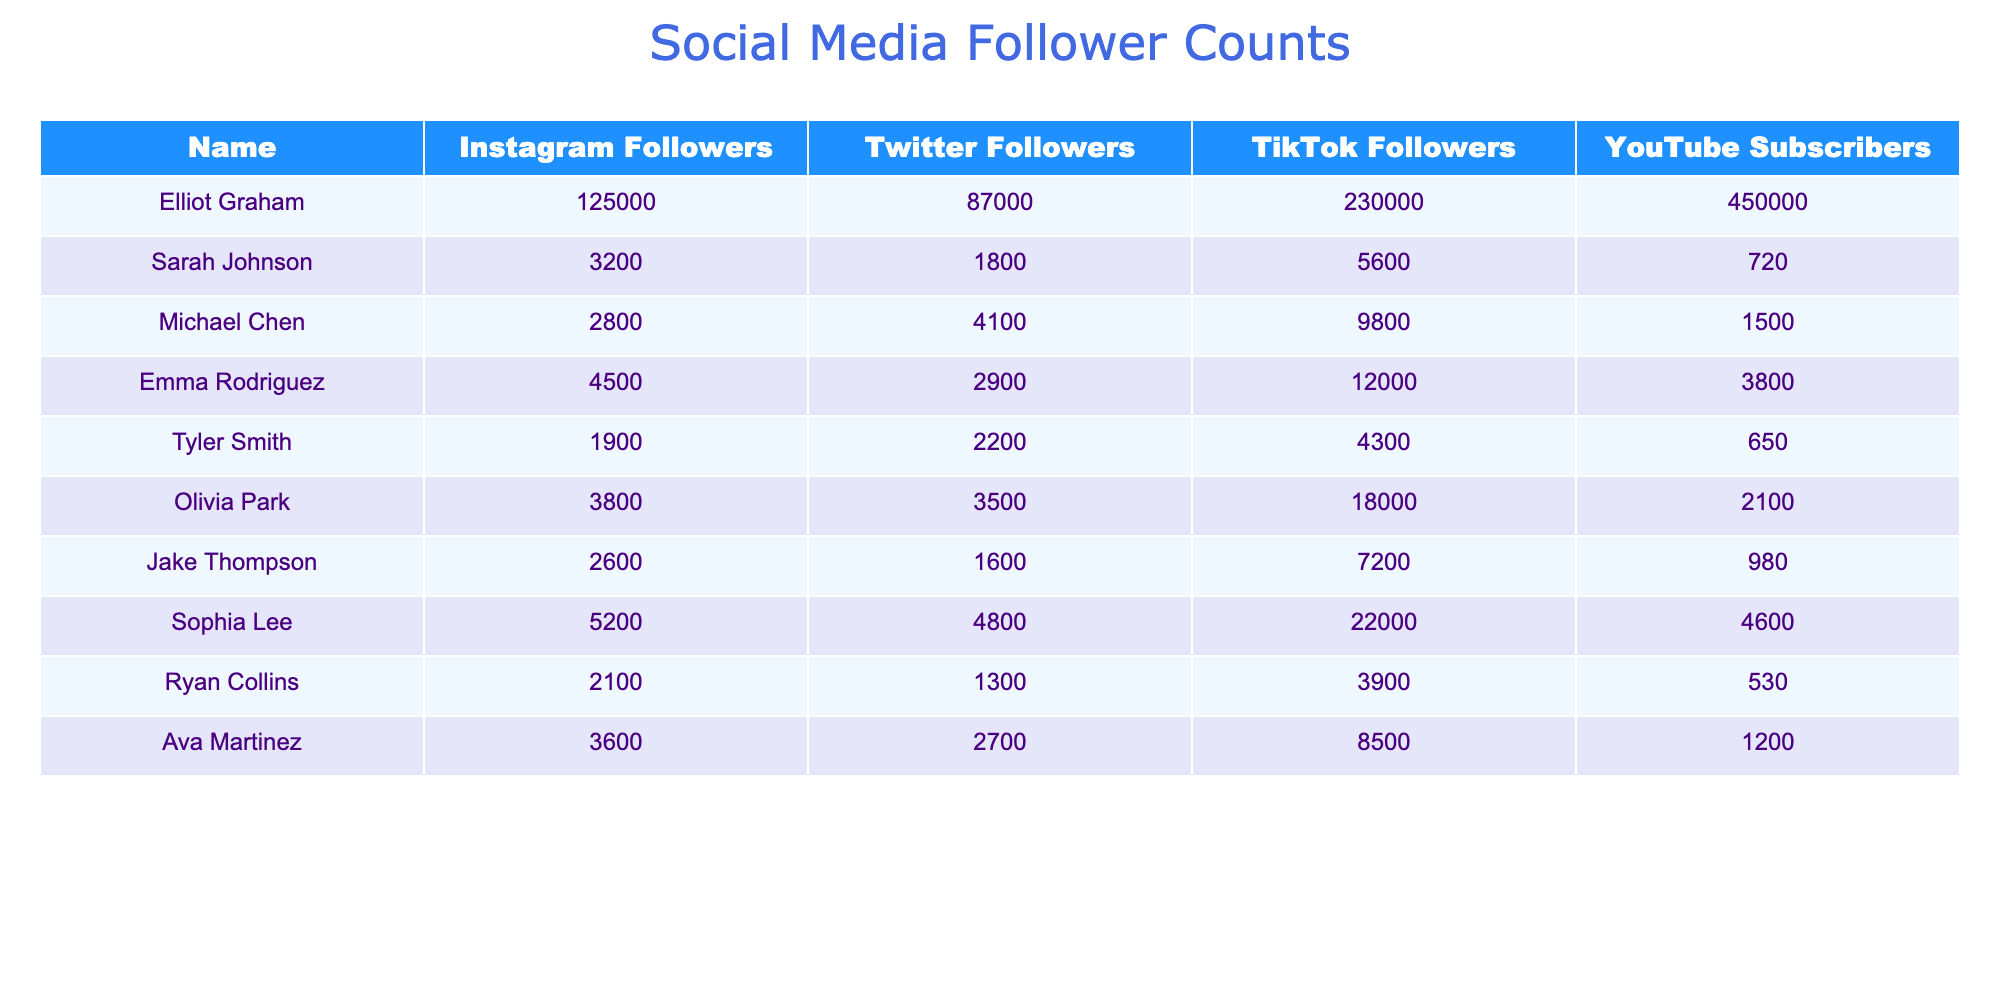What is Elliot Graham's total number of followers across all platforms? To find Elliot Graham's total followers, we add his followers from Instagram (125,000), Twitter (87,000), TikTok (230,000), and YouTube (450,000): 125000 + 87000 + 230000 + 450000 = 892000.
Answer: 892000 Which classmate has the most followers on TikTok? By comparing the TikTok follower counts, we see that Elliot Graham has 230,000 followers, which is more than any other classmate's TikTok counts.
Answer: Elliot Graham What is the average number of YouTube subscribers for the classmates listed? First, we list the YouTube subscribers: 450000 (Elliot) + 720 (Sarah) + 1500 (Michael) + 3800 (Emma) + 650 (Tyler) + 2100 (Olivia) + 980 (Jake) + 4600 (Sophia) + 530 (Ryan) + 1200 (Ava) = 456080. There are 10 classmates, so the average is 456080 / 10 = 45608.
Answer: 45608 Does Sarah Johnson have more Twitter followers than Emma Rodriguez? Sarah Johnson has 1,800 Twitter followers while Emma Rodriguez has 2,900. Since 1,800 is less than 2,900, the answer is no.
Answer: No Who has the least number of followers across all platforms combined? We calculate the total followers for each classmate and find the minimum. For instance, Sarah Johnson: 3200 + 1800 + 5600 + 720 = 11200; Michael Chen: 2800 + 4100 + 9800 + 1500 = 18200; and so on. Olivia Park has the least total with 3500 + 3800 + 18000 + 2100 = 26500 followers.
Answer: Sarah Johnson What is the difference in the number of Instagram followers between Elliot Graham and Sophia Lee? Elliot Graham has 125,000 Instagram followers and Sophia Lee has 5,200. The difference is 125000 - 5200 = 119800.
Answer: 119800 Who has more total followers: Tyler Smith or Ava Martinez? Tyler Smith: 1900 + 2200 + 4300 + 650 = 10150; Ava Martinez: 3600 + 2700 + 8500 + 1200 = 16000. Since 16000 is greater than 10150, Ava Martinez has more total followers than Tyler Smith.
Answer: Ava Martinez What percentage of Elliot Graham's total followers come from TikTok? Elliot's TikTok followers are 230,000 and his total fans are 892,000. The percentage is (230000 / 892000) * 100 ≈ 25.8%.
Answer: 25.8% Which platform gives Sarah Johnson the highest follower count? Sarah Johnson has 3,200 on Instagram, 1,800 on Twitter, 5,600 on TikTok, and 720 on YouTube. The highest count is from TikTok.
Answer: TikTok Are there any classmates with fewer than 5,000 total followers? Calculating the totals, Sarah Johnson has 11,200, Michael Chen has 18,200, and others have higher totals, confirming that no one else falls below 5,000 followers. Therefore, the answer is yes, only Sarah Johnson does.
Answer: Yes, only Sarah Johnson What classmate has the highest number of followers on Instagram and what is that number? By comparing, Elliot Graham has 125,000 followers on Instagram, which is the highest amount compared to others.
Answer: Elliot Graham, 125000 